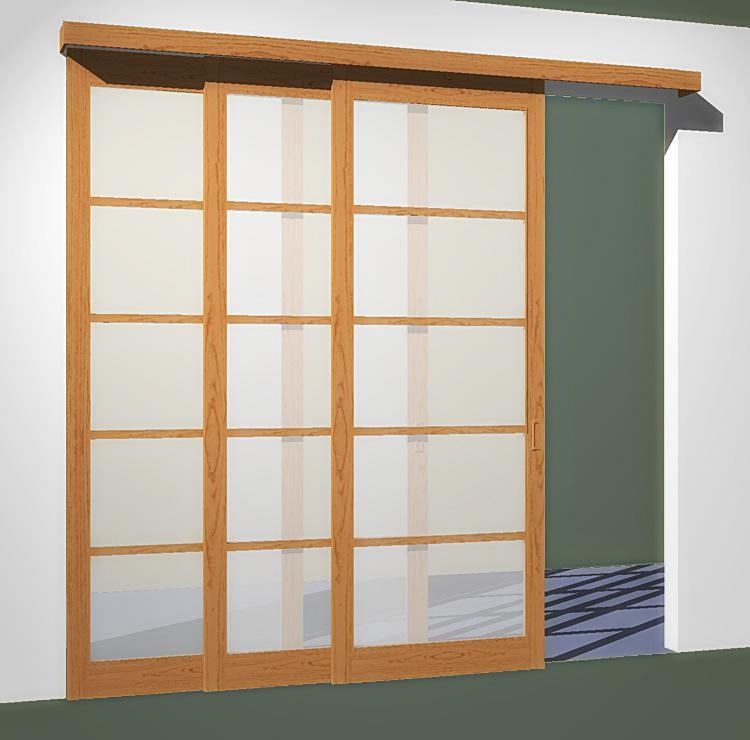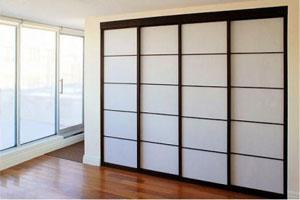The first image is the image on the left, the second image is the image on the right. Given the left and right images, does the statement "The door in one of the images is ajar." hold true? Answer yes or no. Yes. The first image is the image on the left, the second image is the image on the right. For the images shown, is this caption "An image shows a silver-framed sliding door unit with three plain glass panels." true? Answer yes or no. No. 